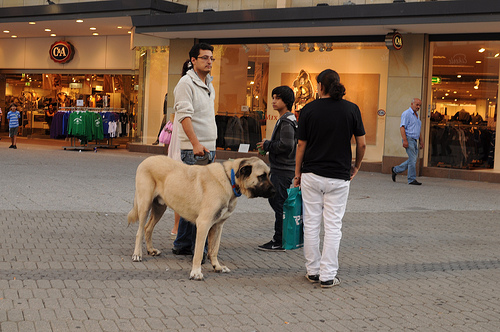Is the man to the left of the woman holding onto a dog? Yes, the man standing to the left of the woman is indeed holding onto a large dog, which seems to be well-behaved. 